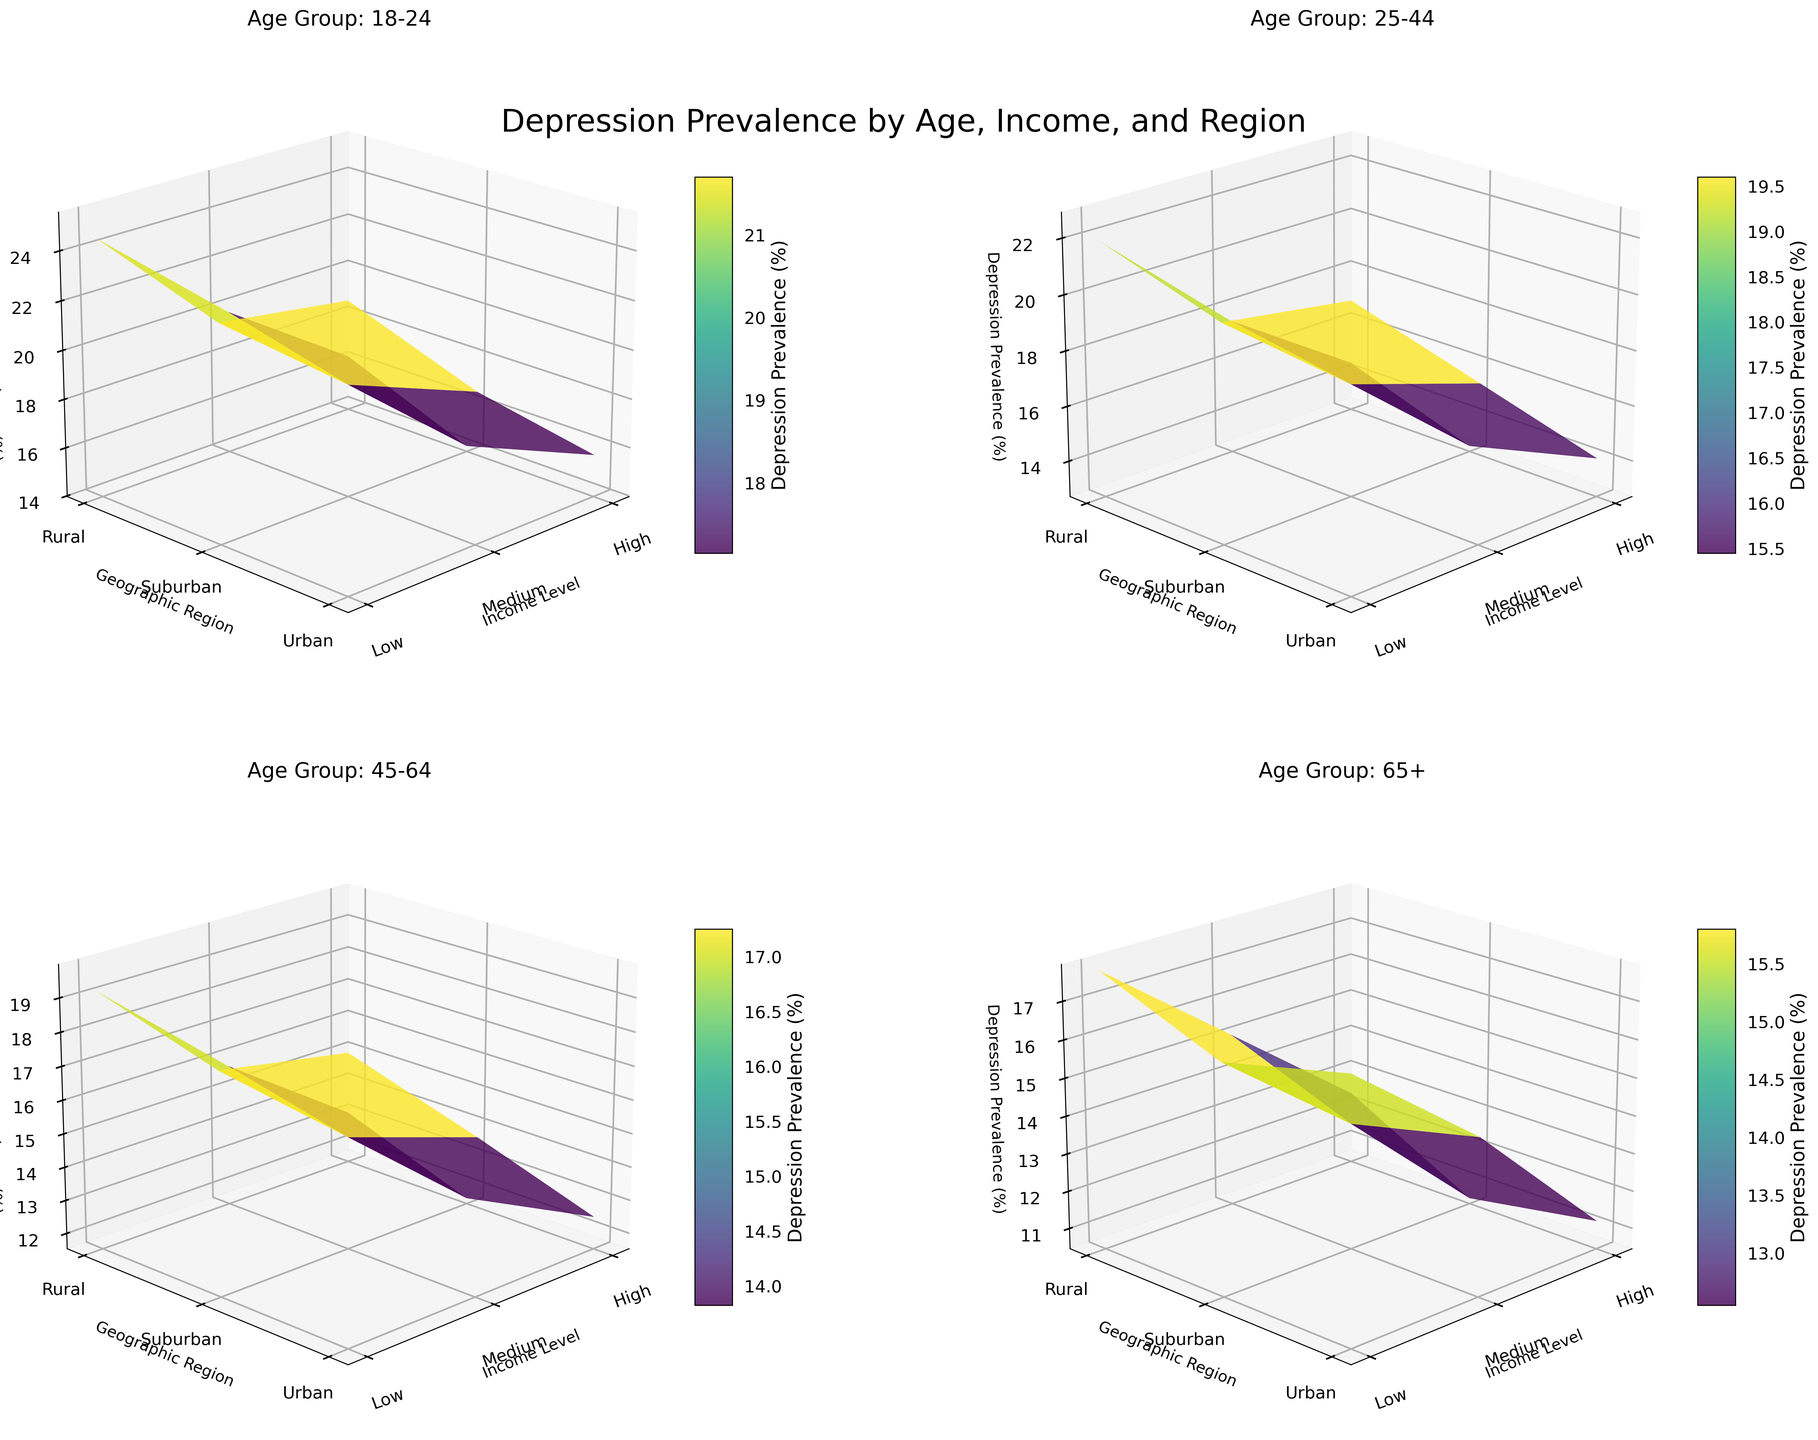What are the axis labels for each subplot? Each subplot has three-axis labels: 'Income Level' on the x-axis, 'Geographic Region' on the y-axis, and 'Depression Prevalence (%)' on the z-axis.
Answer: 'Income Level', 'Geographic Region', 'Depression Prevalence (%)' Which age group shows the highest depression prevalence in rural areas for low-income levels? By examining the plots, the subplot for the '18-24' age group shows the highest depression prevalence in rural areas for low-income levels with a percentage of 24.5%.
Answer: Age Group '18-24' Comparing urban regions, which age group has the lowest depression prevalence for high-income levels? Look at the z-values for 'High' income levels in each age group's urban regions. The '65+' age group has the lowest depression prevalence for high-income levels in urban regions, with 11.2%.
Answer: Age Group '65+' What is the average depression prevalence in suburban regions for medium-income levels across all age groups? Find the values for suburban regions with medium income in all subplots: 18.6, 16.8, 14.9, and 13.8. Calculate the average: (18.6 + 16.8 + 14.9 + 13.8) / 4 = 16.03%.
Answer: 16.03% Does depression prevalence generally increase, decrease, or stay the same as income level increases in the '25-44' age group? Look at the depression prevalence values for the '25-44' age group across different income levels. Depression prevalence decreases as income level increases.
Answer: Decreases Across all age groups, which geographic region shows the most significant decrease in depression prevalence when moving from low to high income? Compare the differences in depression prevalence between low and high income in each geographic region for all age groups. The Suburban region shows the most significant decreases.
Answer: Suburban For the '45-64' age group, does the depression prevalence in rural regions for high-income levels exceed any other income levels in urban and suburban regions? For '45-64', high-income in rural regions is 13.1. Check other regions: Urban (12.5 high, 16.2 medium, 19.8 low), Suburban (11.7 high, 14.9 medium, 18.1 low). Only surpasses high-income in urban and suburban regions.
Answer: No 